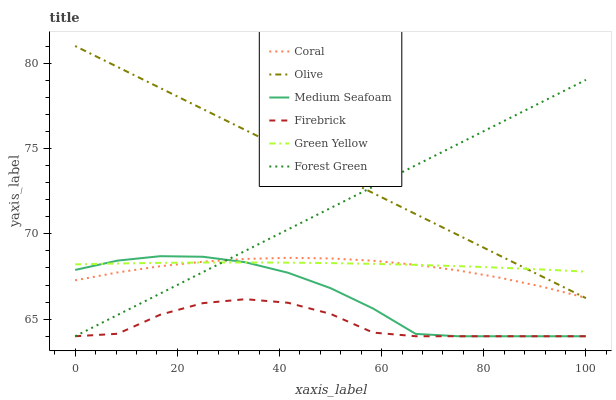Does Firebrick have the minimum area under the curve?
Answer yes or no. Yes. Does Olive have the maximum area under the curve?
Answer yes or no. Yes. Does Medium Seafoam have the minimum area under the curve?
Answer yes or no. No. Does Medium Seafoam have the maximum area under the curve?
Answer yes or no. No. Is Olive the smoothest?
Answer yes or no. Yes. Is Firebrick the roughest?
Answer yes or no. Yes. Is Medium Seafoam the smoothest?
Answer yes or no. No. Is Medium Seafoam the roughest?
Answer yes or no. No. Does Firebrick have the lowest value?
Answer yes or no. Yes. Does Olive have the lowest value?
Answer yes or no. No. Does Olive have the highest value?
Answer yes or no. Yes. Does Medium Seafoam have the highest value?
Answer yes or no. No. Is Firebrick less than Coral?
Answer yes or no. Yes. Is Olive greater than Firebrick?
Answer yes or no. Yes. Does Forest Green intersect Coral?
Answer yes or no. Yes. Is Forest Green less than Coral?
Answer yes or no. No. Is Forest Green greater than Coral?
Answer yes or no. No. Does Firebrick intersect Coral?
Answer yes or no. No. 